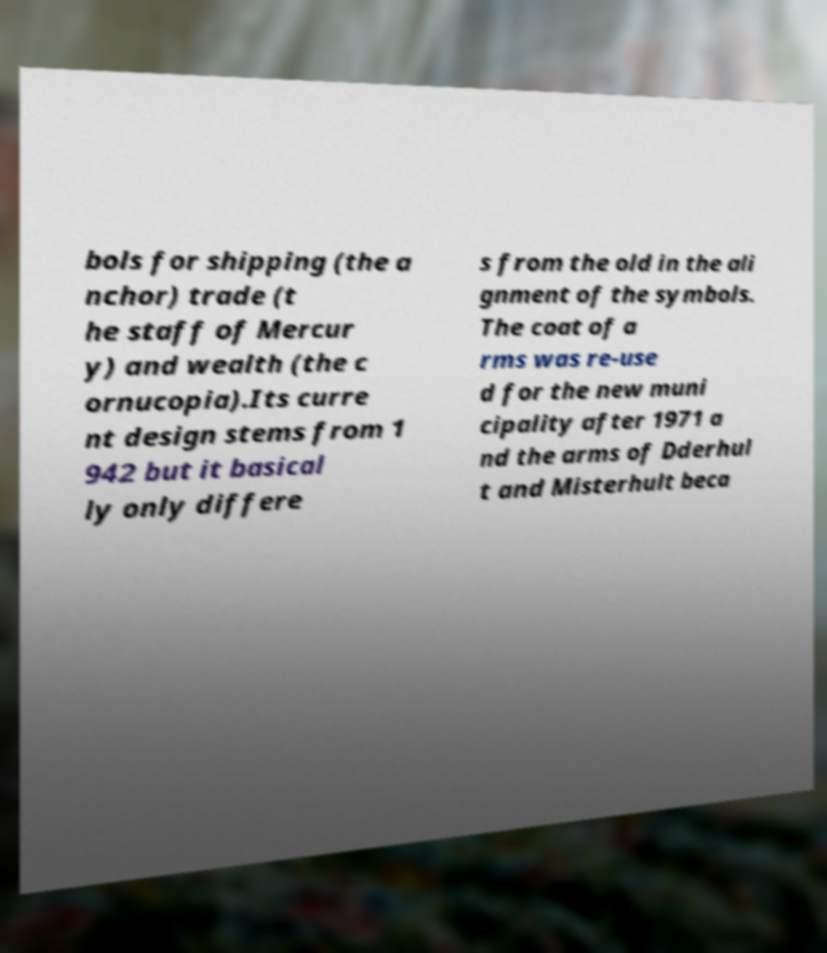Could you assist in decoding the text presented in this image and type it out clearly? bols for shipping (the a nchor) trade (t he staff of Mercur y) and wealth (the c ornucopia).Its curre nt design stems from 1 942 but it basical ly only differe s from the old in the ali gnment of the symbols. The coat of a rms was re-use d for the new muni cipality after 1971 a nd the arms of Dderhul t and Misterhult beca 